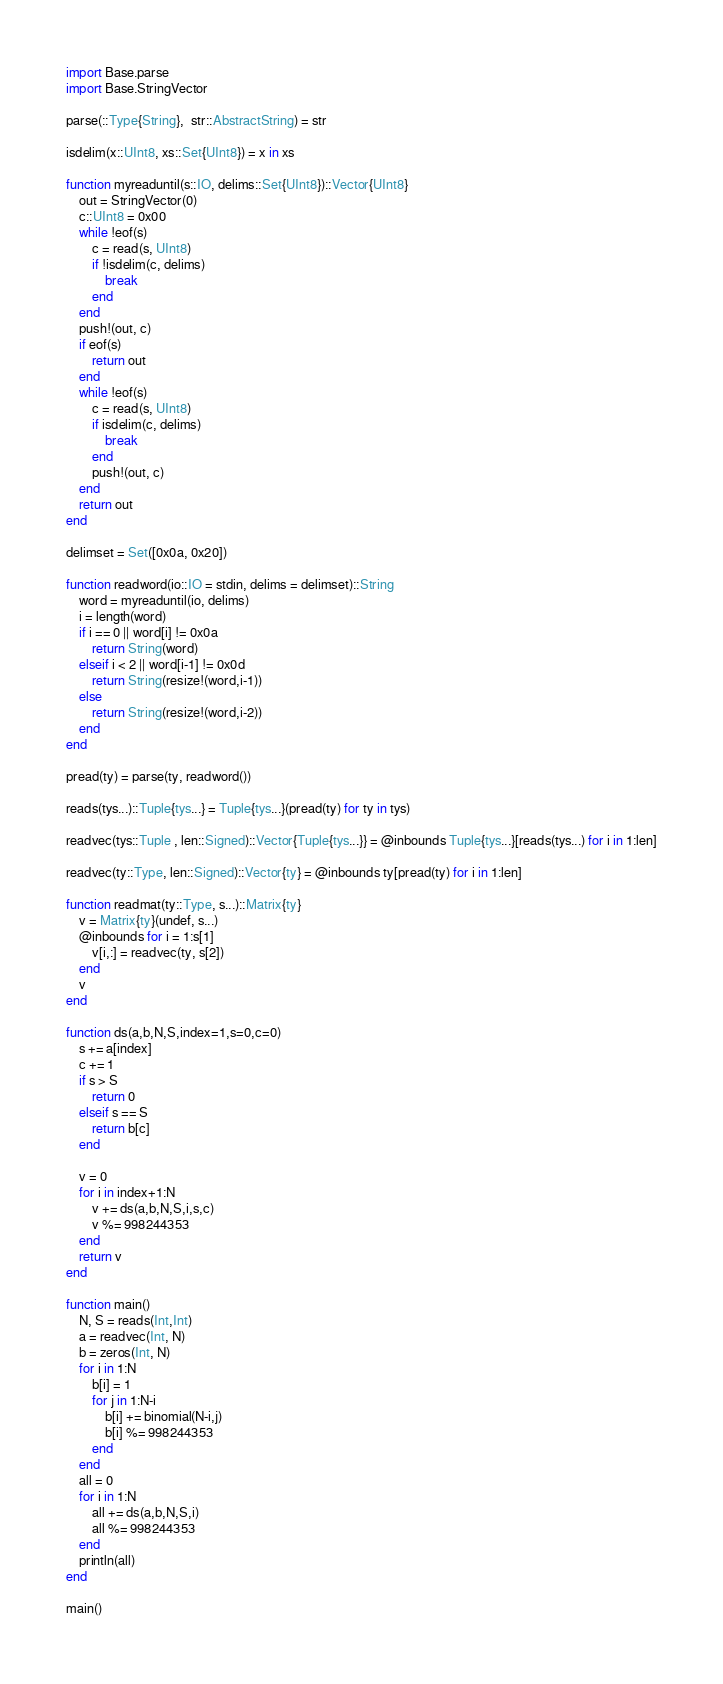Convert code to text. <code><loc_0><loc_0><loc_500><loc_500><_Julia_>import Base.parse
import Base.StringVector

parse(::Type{String},  str::AbstractString) = str

isdelim(x::UInt8, xs::Set{UInt8}) = x in xs

function myreaduntil(s::IO, delims::Set{UInt8})::Vector{UInt8}
    out = StringVector(0)
    c::UInt8 = 0x00
    while !eof(s)
        c = read(s, UInt8)
        if !isdelim(c, delims)
            break
        end
    end
    push!(out, c)
    if eof(s)
        return out
    end
    while !eof(s)
        c = read(s, UInt8)
        if isdelim(c, delims)
            break
        end
        push!(out, c)
    end
    return out
end

delimset = Set([0x0a, 0x20])

function readword(io::IO = stdin, delims = delimset)::String
    word = myreaduntil(io, delims)
    i = length(word)
    if i == 0 || word[i] != 0x0a
        return String(word)
    elseif i < 2 || word[i-1] != 0x0d
        return String(resize!(word,i-1))
    else
        return String(resize!(word,i-2))
    end
end

pread(ty) = parse(ty, readword())

reads(tys...)::Tuple{tys...} = Tuple{tys...}(pread(ty) for ty in tys)

readvec(tys::Tuple , len::Signed)::Vector{Tuple{tys...}} = @inbounds Tuple{tys...}[reads(tys...) for i in 1:len]

readvec(ty::Type, len::Signed)::Vector{ty} = @inbounds ty[pread(ty) for i in 1:len]

function readmat(ty::Type, s...)::Matrix{ty}
    v = Matrix{ty}(undef, s...)
    @inbounds for i = 1:s[1]
        v[i,:] = readvec(ty, s[2])
    end
    v
end

function ds(a,b,N,S,index=1,s=0,c=0)
    s += a[index]
    c += 1
    if s > S
        return 0
    elseif s == S
        return b[c]
    end

    v = 0
    for i in index+1:N
        v += ds(a,b,N,S,i,s,c)
        v %= 998244353
    end
    return v
end

function main()
    N, S = reads(Int,Int)
    a = readvec(Int, N)
    b = zeros(Int, N)
    for i in 1:N
        b[i] = 1
        for j in 1:N-i
            b[i] += binomial(N-i,j)
            b[i] %= 998244353
        end
    end
    all = 0
    for i in 1:N
        all += ds(a,b,N,S,i)
        all %= 998244353
    end
    println(all)
end

main()
</code> 